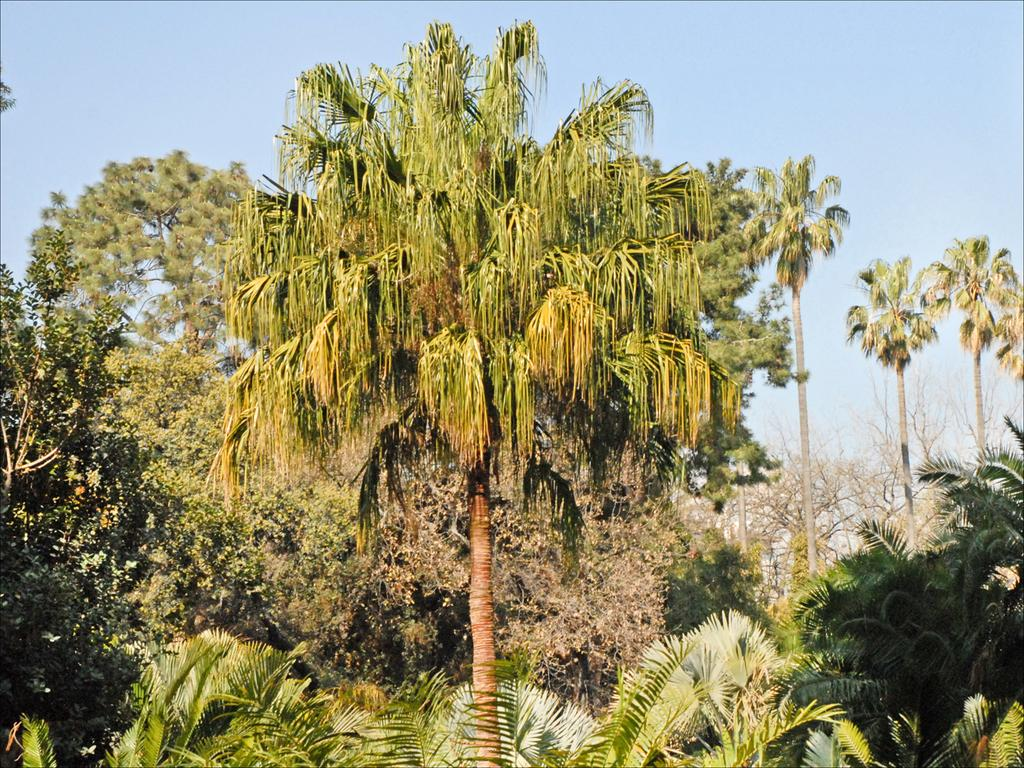What type of trees can be seen in the image? There are big green trees and small trees in the image. What is visible at the top of the image? The sky is visible at the top of the image. What type of test is being conducted on the carpenter in the image? There is no carpenter or test present in the image; it features trees and a sky. 